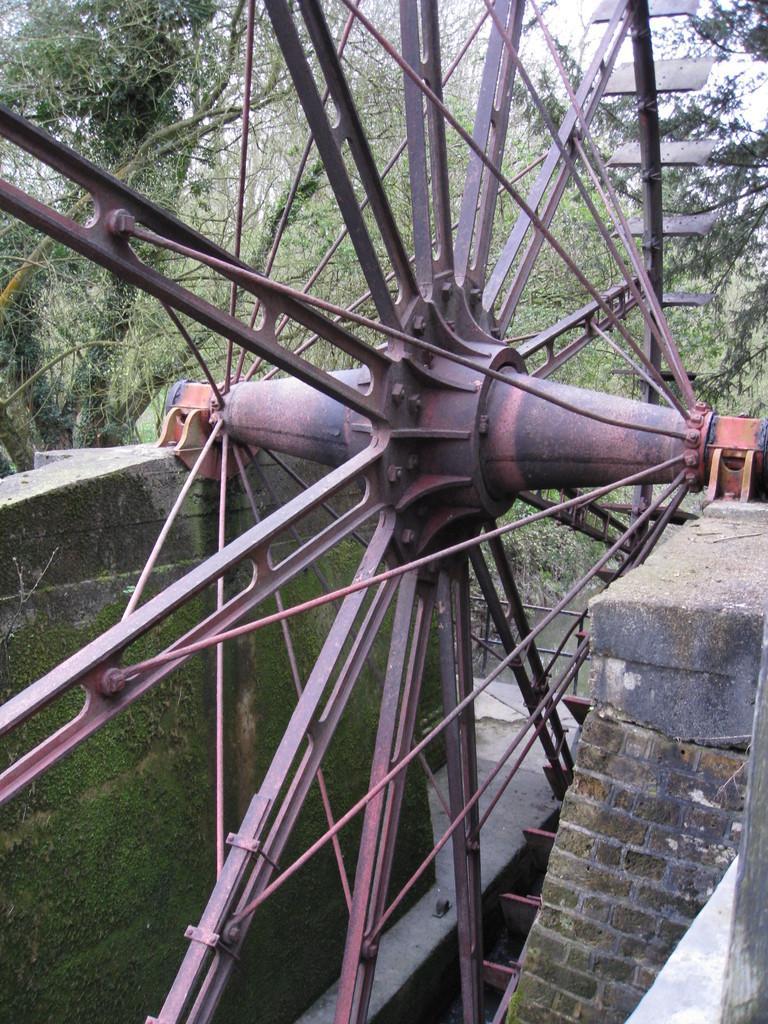In one or two sentences, can you explain what this image depicts? In this picture I can see there is a huge wheel, it has iron frames and it is placed in between these two walls and there are trees in the backdrop and the sky is clear. 